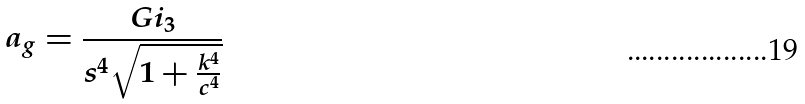<formula> <loc_0><loc_0><loc_500><loc_500>a _ { g } = \frac { G i _ { 3 } } { s ^ { 4 } \sqrt { 1 + \frac { k ^ { 4 } } { c ^ { 4 } } } }</formula> 